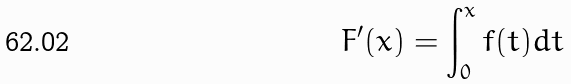Convert formula to latex. <formula><loc_0><loc_0><loc_500><loc_500>F ^ { \prime } ( x ) = \int _ { 0 } ^ { x } f ( t ) d t</formula> 